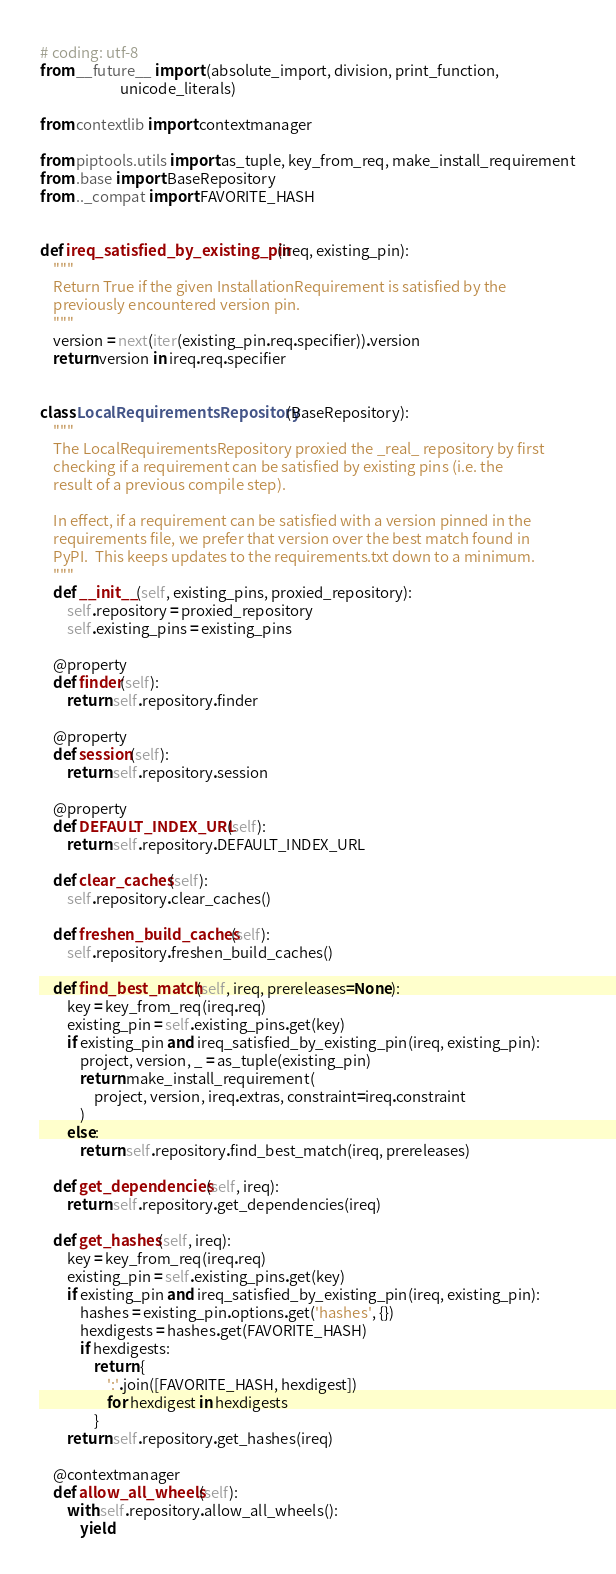<code> <loc_0><loc_0><loc_500><loc_500><_Python_># coding: utf-8
from __future__ import (absolute_import, division, print_function,
                        unicode_literals)

from contextlib import contextmanager

from piptools.utils import as_tuple, key_from_req, make_install_requirement
from .base import BaseRepository
from .._compat import FAVORITE_HASH


def ireq_satisfied_by_existing_pin(ireq, existing_pin):
    """
    Return True if the given InstallationRequirement is satisfied by the
    previously encountered version pin.
    """
    version = next(iter(existing_pin.req.specifier)).version
    return version in ireq.req.specifier


class LocalRequirementsRepository(BaseRepository):
    """
    The LocalRequirementsRepository proxied the _real_ repository by first
    checking if a requirement can be satisfied by existing pins (i.e. the
    result of a previous compile step).

    In effect, if a requirement can be satisfied with a version pinned in the
    requirements file, we prefer that version over the best match found in
    PyPI.  This keeps updates to the requirements.txt down to a minimum.
    """
    def __init__(self, existing_pins, proxied_repository):
        self.repository = proxied_repository
        self.existing_pins = existing_pins

    @property
    def finder(self):
        return self.repository.finder

    @property
    def session(self):
        return self.repository.session

    @property
    def DEFAULT_INDEX_URL(self):
        return self.repository.DEFAULT_INDEX_URL

    def clear_caches(self):
        self.repository.clear_caches()

    def freshen_build_caches(self):
        self.repository.freshen_build_caches()

    def find_best_match(self, ireq, prereleases=None):
        key = key_from_req(ireq.req)
        existing_pin = self.existing_pins.get(key)
        if existing_pin and ireq_satisfied_by_existing_pin(ireq, existing_pin):
            project, version, _ = as_tuple(existing_pin)
            return make_install_requirement(
                project, version, ireq.extras, constraint=ireq.constraint
            )
        else:
            return self.repository.find_best_match(ireq, prereleases)

    def get_dependencies(self, ireq):
        return self.repository.get_dependencies(ireq)

    def get_hashes(self, ireq):
        key = key_from_req(ireq.req)
        existing_pin = self.existing_pins.get(key)
        if existing_pin and ireq_satisfied_by_existing_pin(ireq, existing_pin):
            hashes = existing_pin.options.get('hashes', {})
            hexdigests = hashes.get(FAVORITE_HASH)
            if hexdigests:
                return {
                    ':'.join([FAVORITE_HASH, hexdigest])
                    for hexdigest in hexdigests
                }
        return self.repository.get_hashes(ireq)

    @contextmanager
    def allow_all_wheels(self):
        with self.repository.allow_all_wheels():
            yield
</code> 